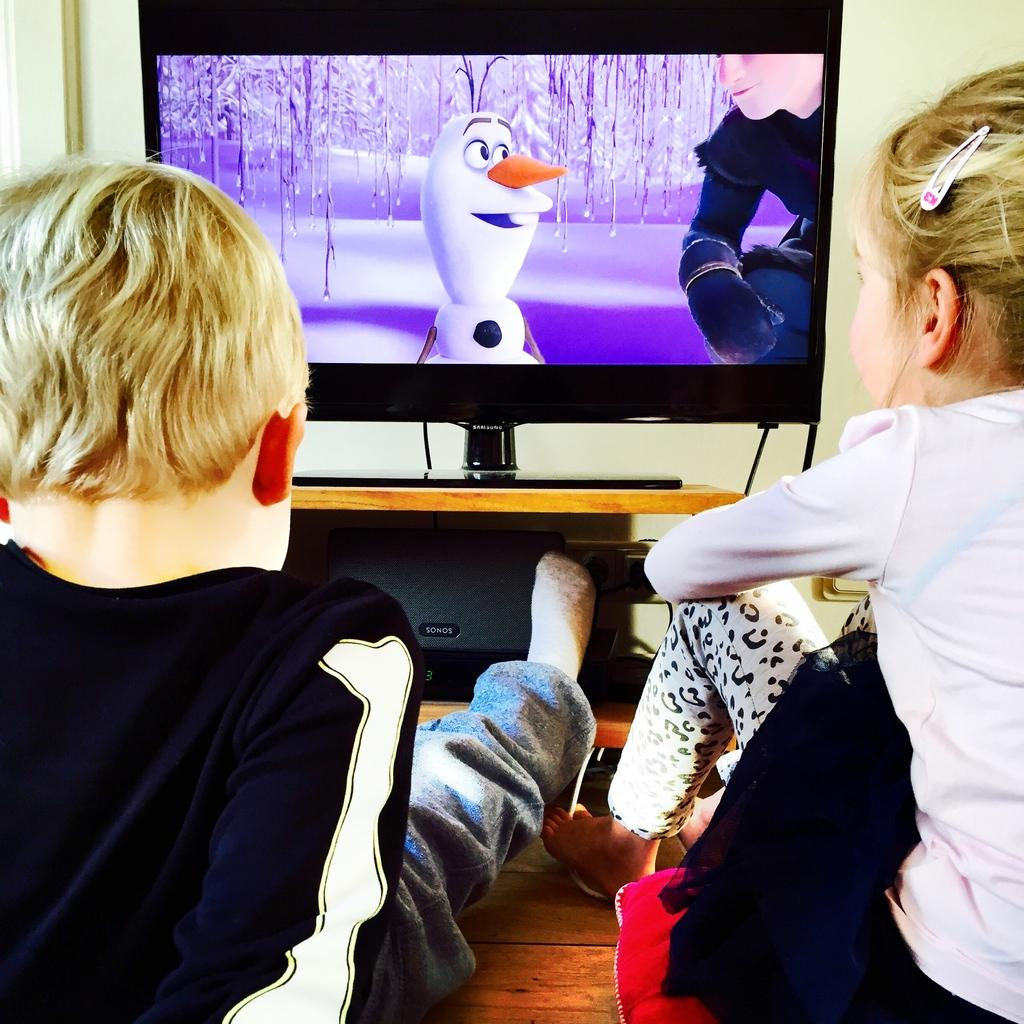What can be seen in the background of the image? There is a wall in the background of the image. What electronic device is present in the image? There is a television in the image. How many people are in the image? There is a girl and a boy in the image. What are the girl and the boy doing in the image? The girl and the boy are sitting and watching television. What holiday is being celebrated in the image? There is no indication of a holiday being celebrated in the image. What scientific theory is being discussed by the girl and the boy in the image? There is no discussion of a scientific theory in the image; they are simply watching television. 